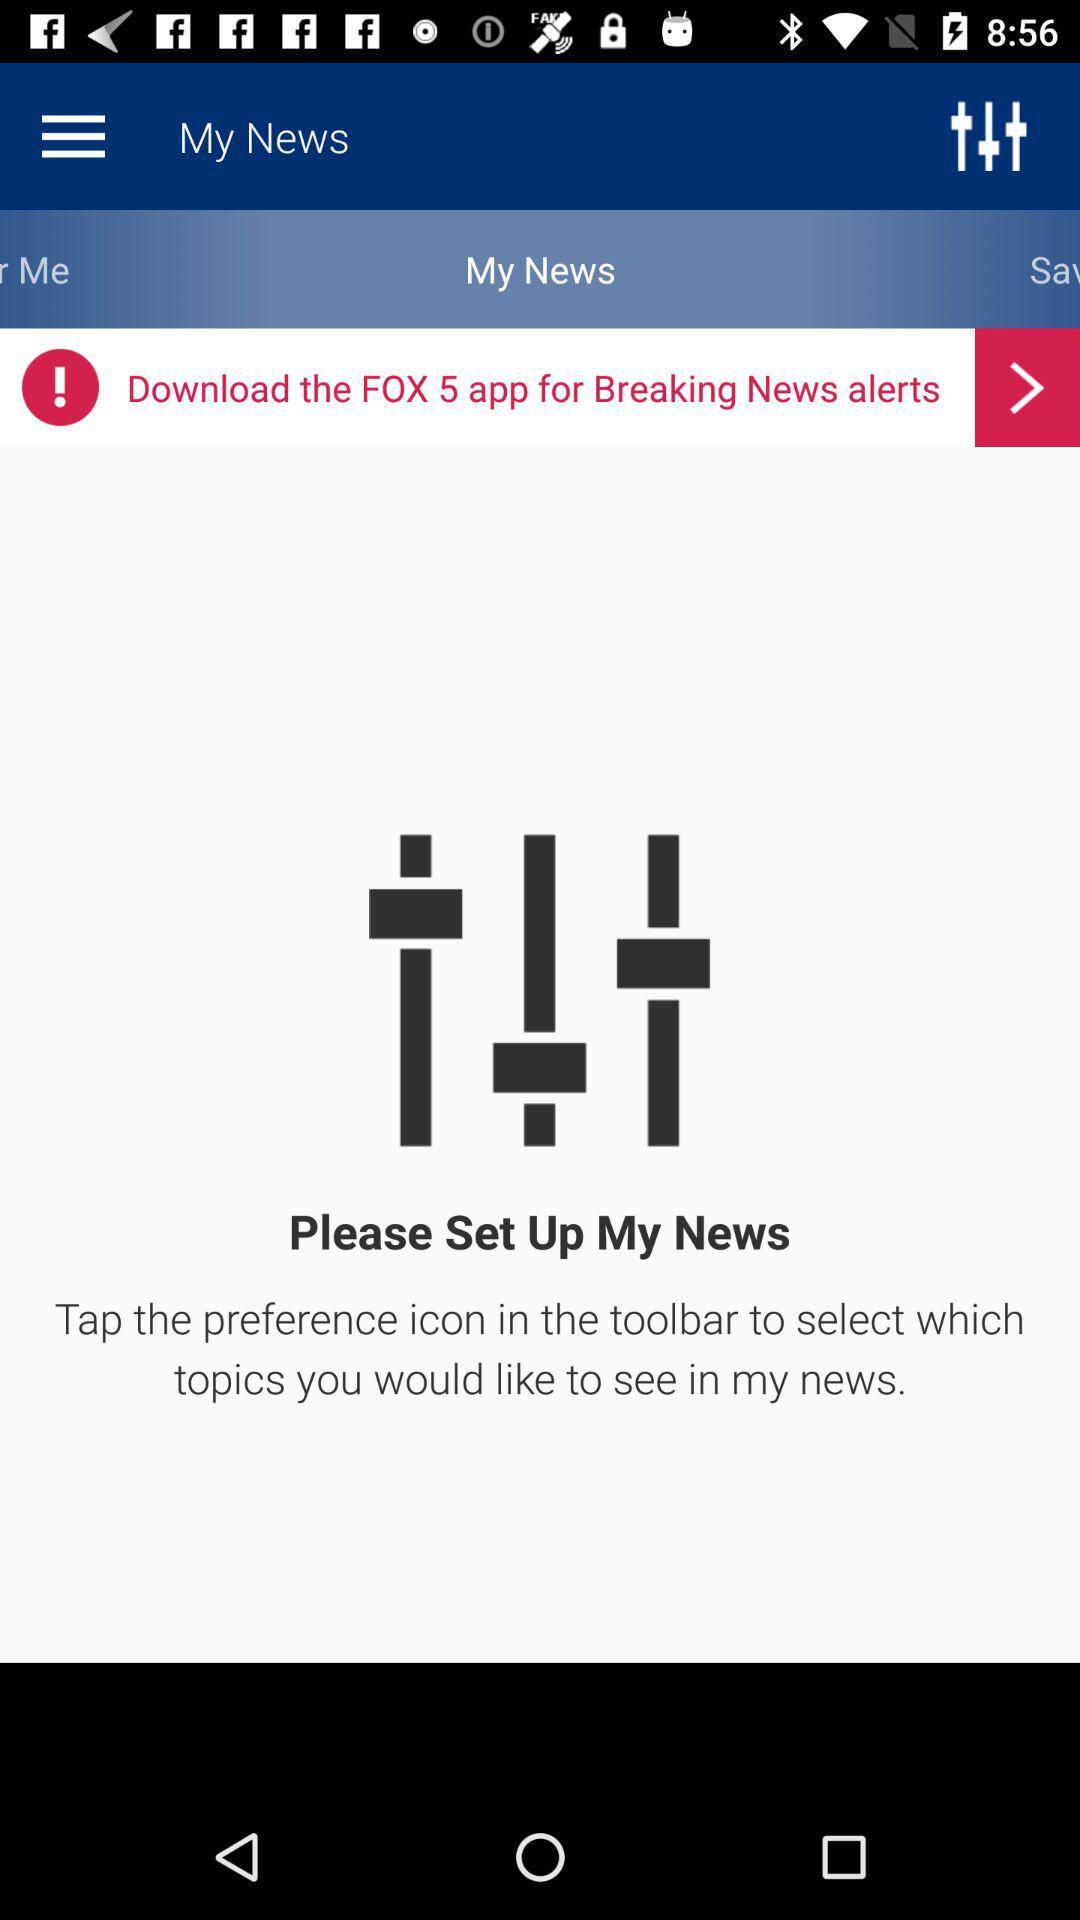What is the name of the app? The name of the app is "FOX 5". 